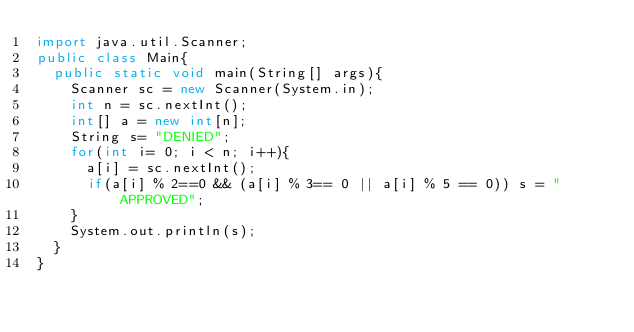Convert code to text. <code><loc_0><loc_0><loc_500><loc_500><_Java_>import java.util.Scanner;
public class Main{
  public static void main(String[] args){
    Scanner sc = new Scanner(System.in);
    int n = sc.nextInt();
    int[] a = new int[n];
    String s= "DENIED";
    for(int i= 0; i < n; i++){
      a[i] = sc.nextInt();
      if(a[i] % 2==0 && (a[i] % 3== 0 || a[i] % 5 == 0)) s = "APPROVED";
    }
    System.out.println(s);
  }
}
</code> 